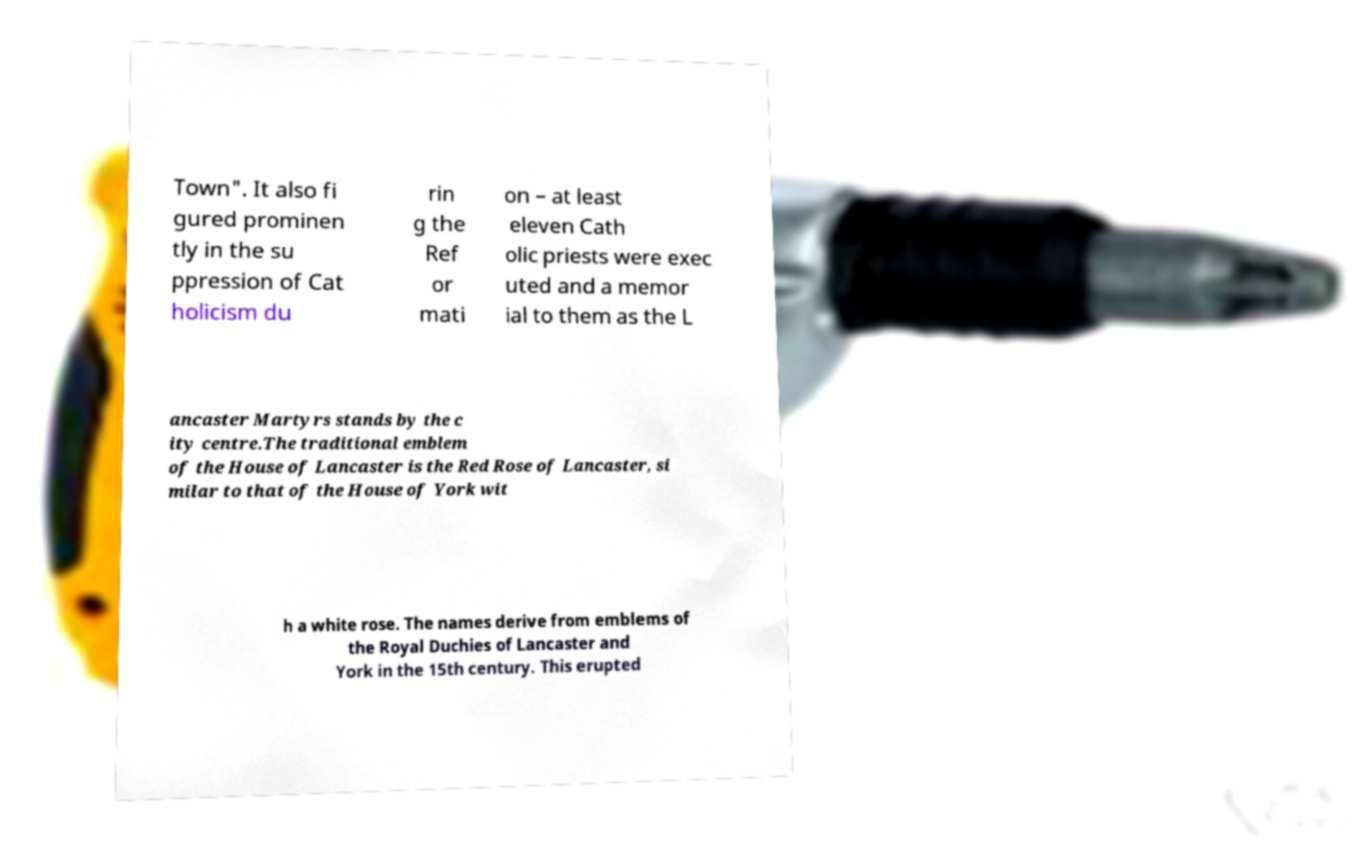Could you assist in decoding the text presented in this image and type it out clearly? Town". It also fi gured prominen tly in the su ppression of Cat holicism du rin g the Ref or mati on – at least eleven Cath olic priests were exec uted and a memor ial to them as the L ancaster Martyrs stands by the c ity centre.The traditional emblem of the House of Lancaster is the Red Rose of Lancaster, si milar to that of the House of York wit h a white rose. The names derive from emblems of the Royal Duchies of Lancaster and York in the 15th century. This erupted 